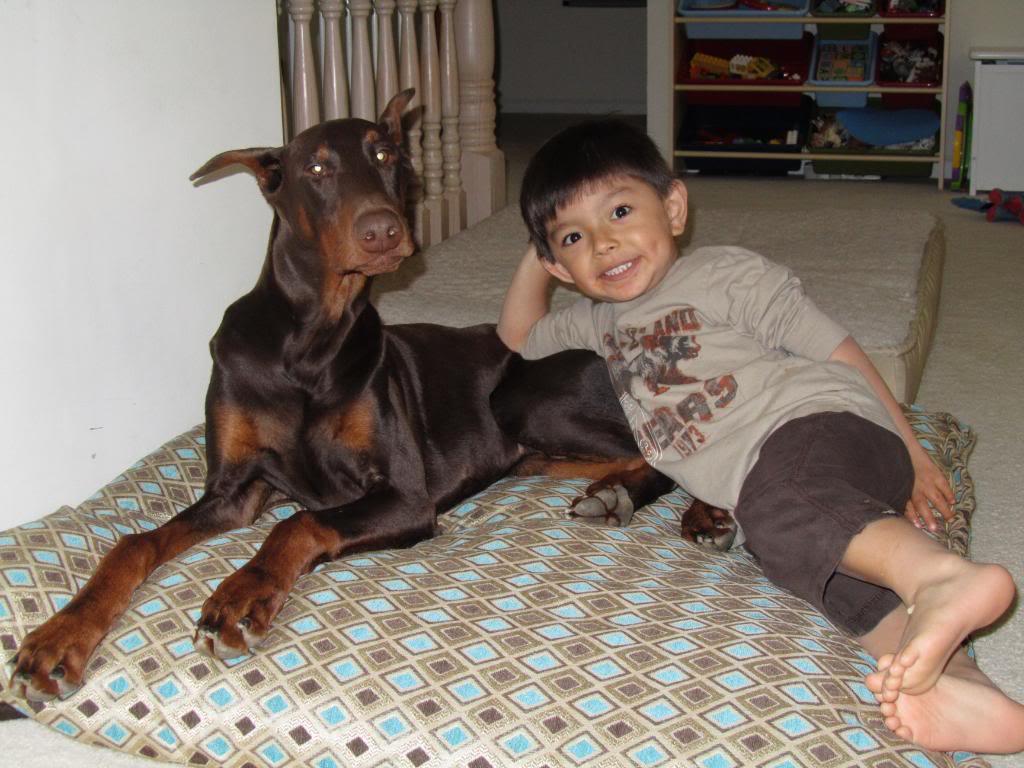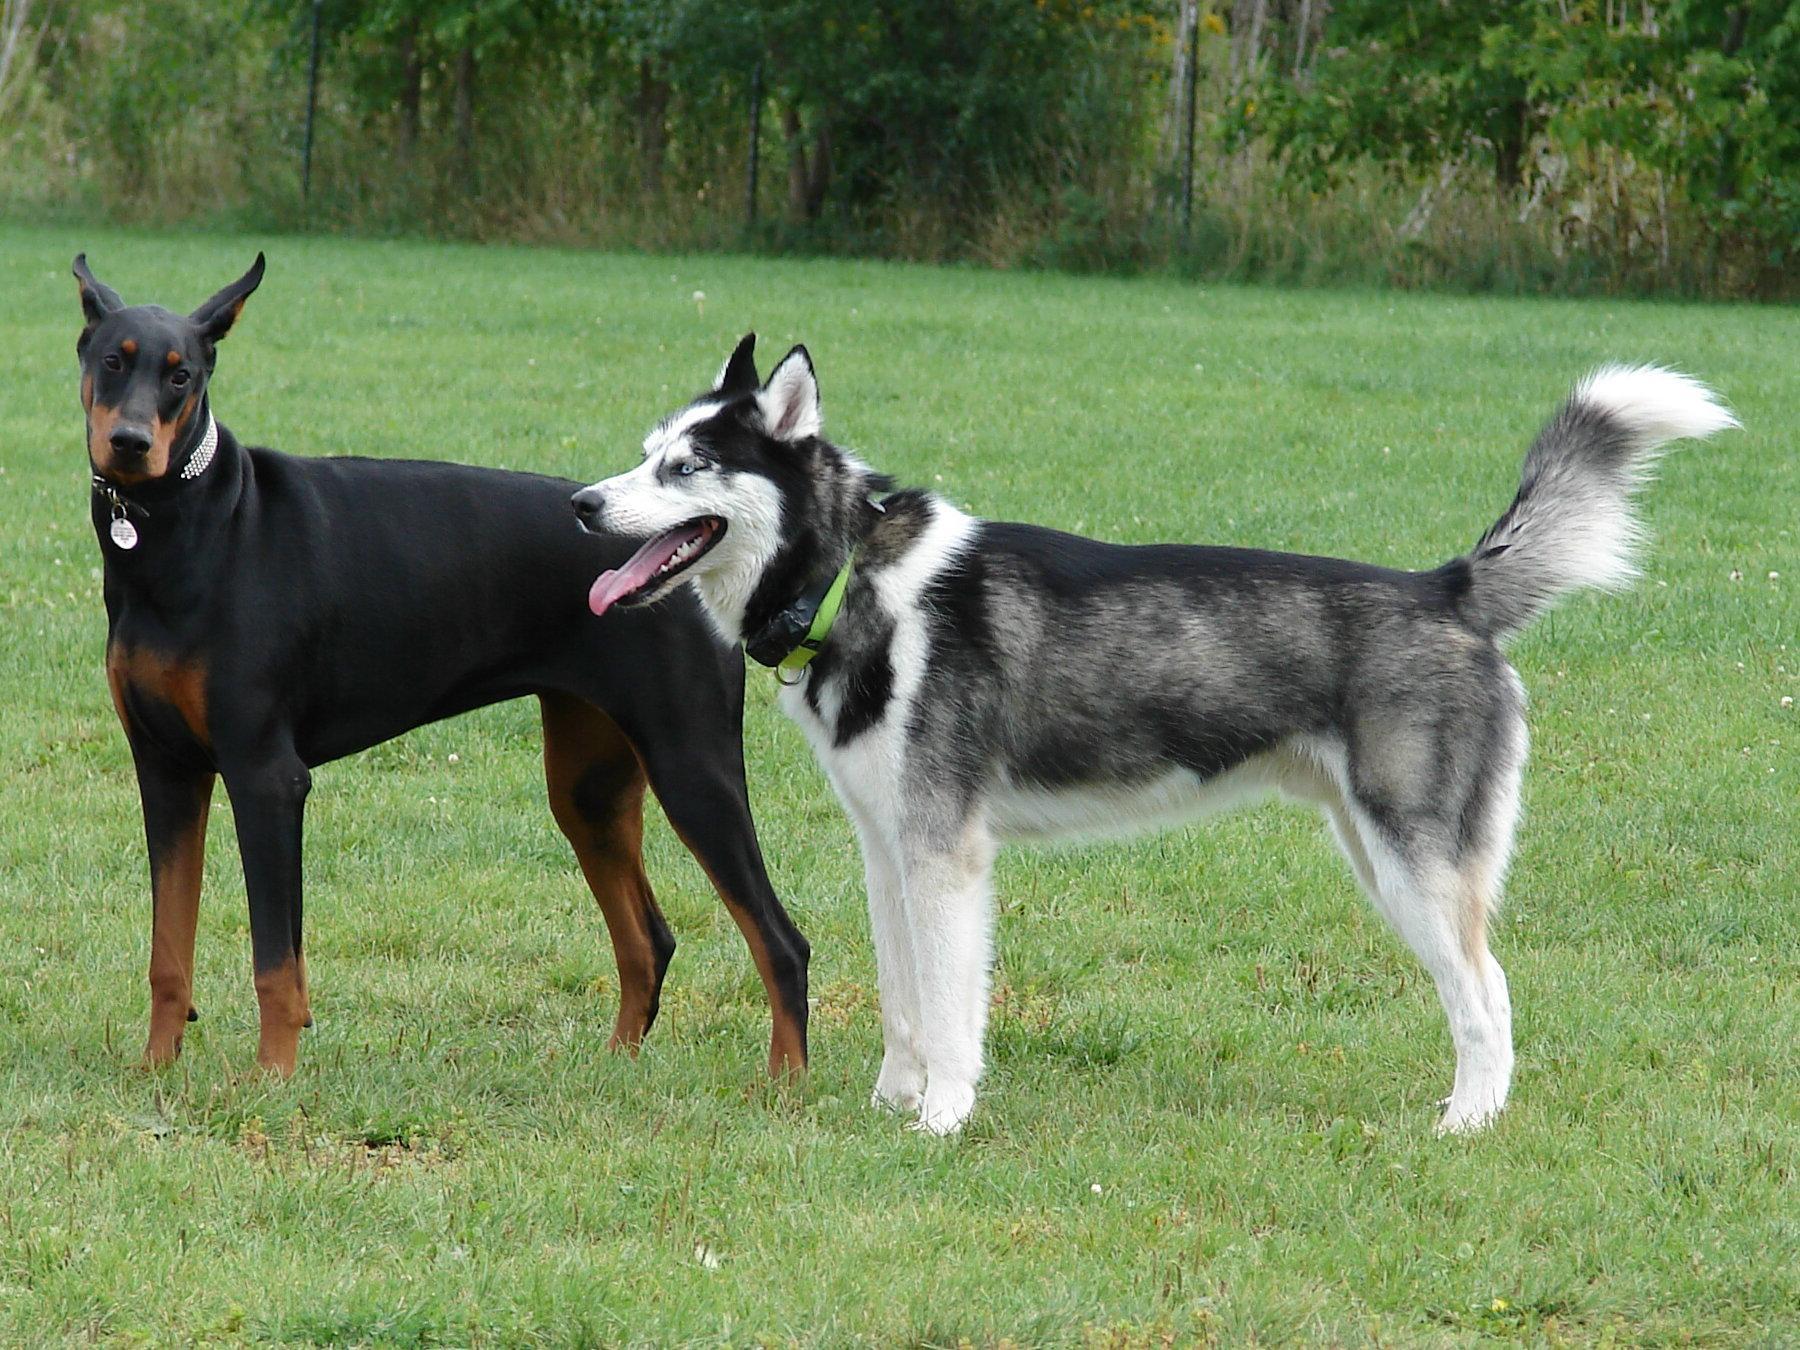The first image is the image on the left, the second image is the image on the right. Considering the images on both sides, is "There are at least three dogs in total." valid? Answer yes or no. Yes. The first image is the image on the left, the second image is the image on the right. Analyze the images presented: Is the assertion "A young girl is sitting next to her doberman pincer." valid? Answer yes or no. No. 